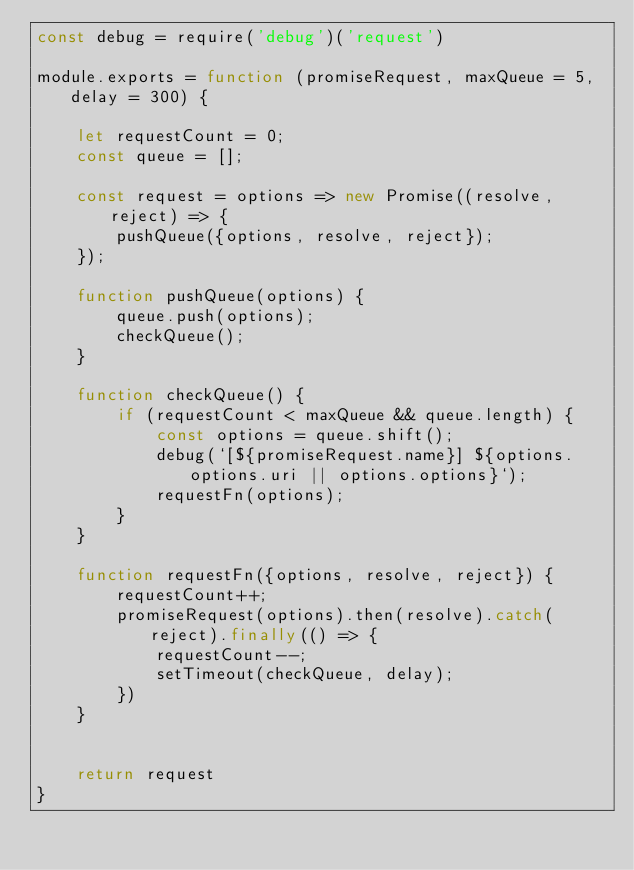<code> <loc_0><loc_0><loc_500><loc_500><_JavaScript_>const debug = require('debug')('request')

module.exports = function (promiseRequest, maxQueue = 5, delay = 300) {

    let requestCount = 0;
    const queue = [];

    const request = options => new Promise((resolve, reject) => {
        pushQueue({options, resolve, reject});
    });

    function pushQueue(options) {
        queue.push(options);
        checkQueue();
    }

    function checkQueue() {
        if (requestCount < maxQueue && queue.length) {
            const options = queue.shift();
            debug(`[${promiseRequest.name}] ${options.options.uri || options.options}`);
            requestFn(options);
        }
    }

    function requestFn({options, resolve, reject}) {
        requestCount++;
        promiseRequest(options).then(resolve).catch(reject).finally(() => {
            requestCount--;
            setTimeout(checkQueue, delay);
        })
    }


    return request
}

</code> 